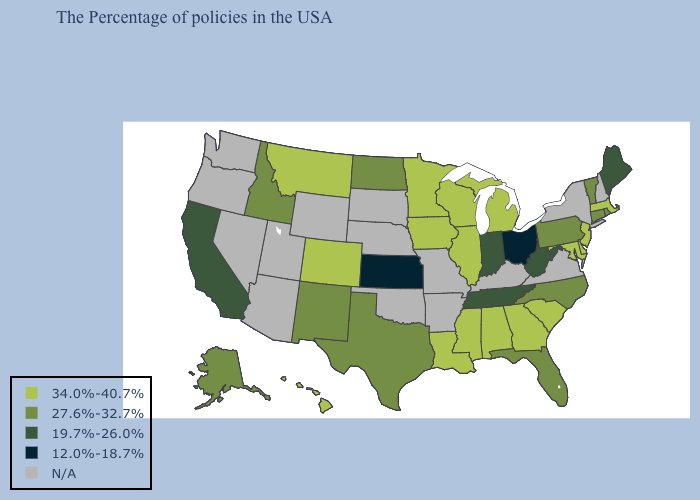What is the value of South Carolina?
Concise answer only. 34.0%-40.7%. What is the highest value in the USA?
Write a very short answer. 34.0%-40.7%. Does the first symbol in the legend represent the smallest category?
Be succinct. No. Among the states that border Louisiana , which have the lowest value?
Be succinct. Texas. What is the value of Wyoming?
Concise answer only. N/A. What is the value of Georgia?
Write a very short answer. 34.0%-40.7%. Name the states that have a value in the range N/A?
Quick response, please. New Hampshire, New York, Virginia, Kentucky, Missouri, Arkansas, Nebraska, Oklahoma, South Dakota, Wyoming, Utah, Arizona, Nevada, Washington, Oregon. Name the states that have a value in the range 19.7%-26.0%?
Concise answer only. Maine, West Virginia, Indiana, Tennessee, California. Name the states that have a value in the range 12.0%-18.7%?
Answer briefly. Ohio, Kansas. Does Alabama have the lowest value in the USA?
Quick response, please. No. 